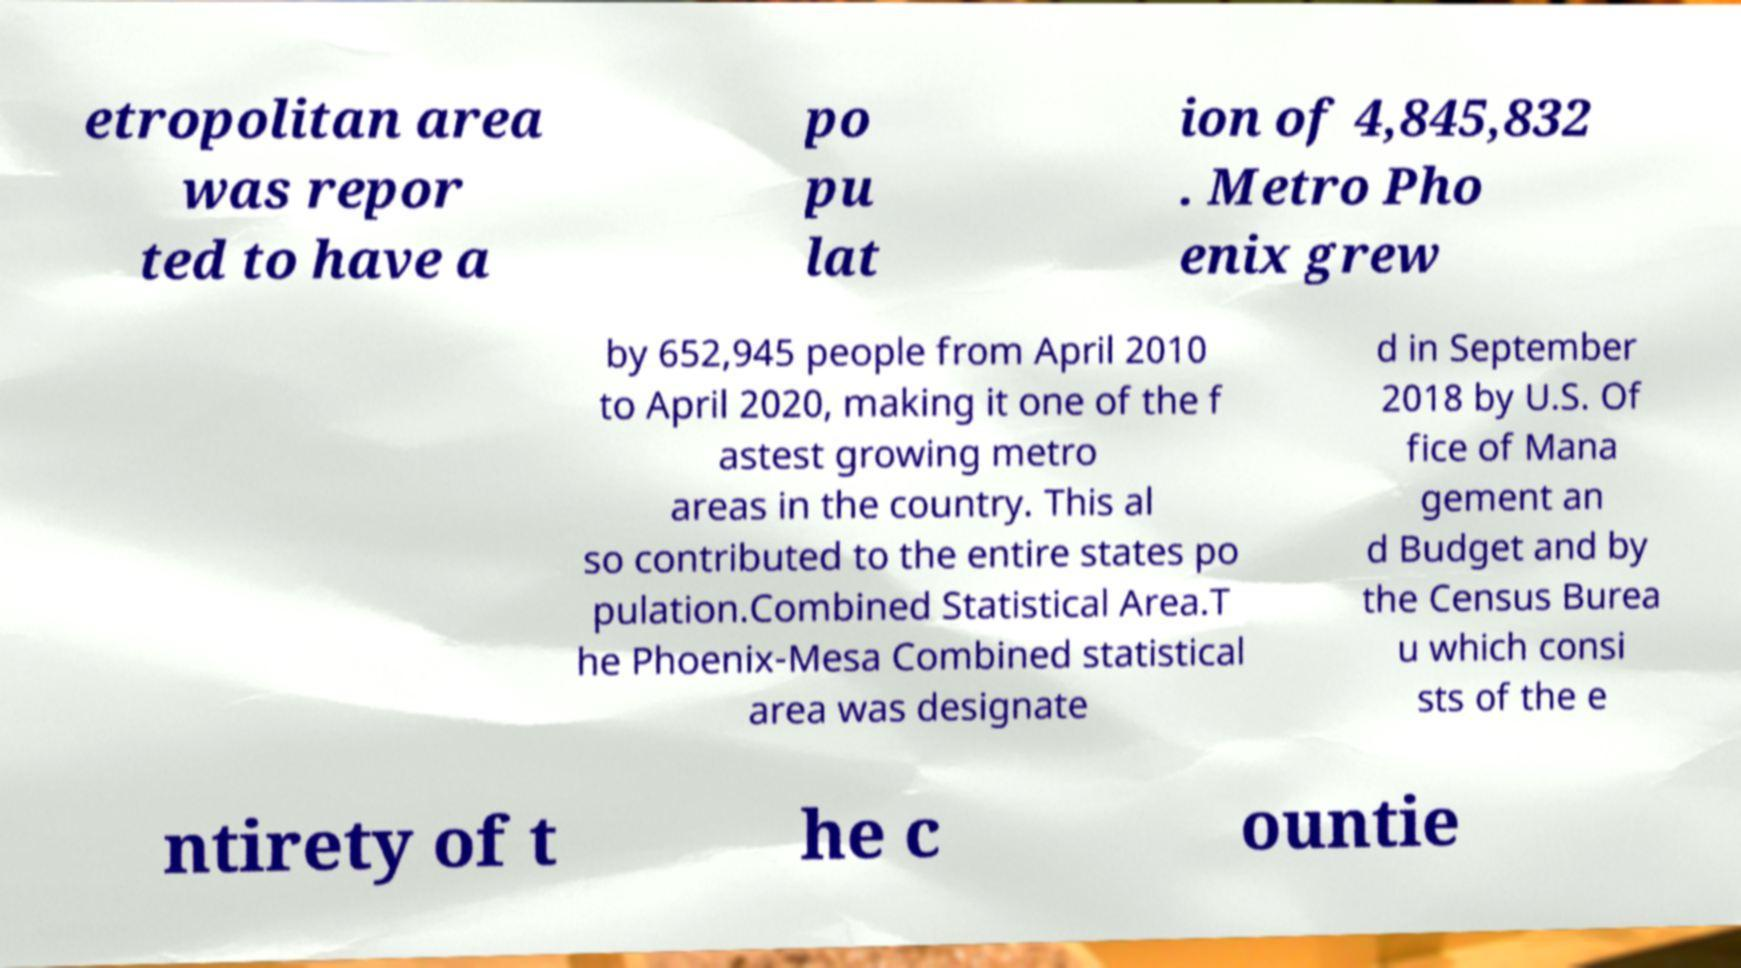Could you extract and type out the text from this image? etropolitan area was repor ted to have a po pu lat ion of 4,845,832 . Metro Pho enix grew by 652,945 people from April 2010 to April 2020, making it one of the f astest growing metro areas in the country. This al so contributed to the entire states po pulation.Combined Statistical Area.T he Phoenix-Mesa Combined statistical area was designate d in September 2018 by U.S. Of fice of Mana gement an d Budget and by the Census Burea u which consi sts of the e ntirety of t he c ountie 